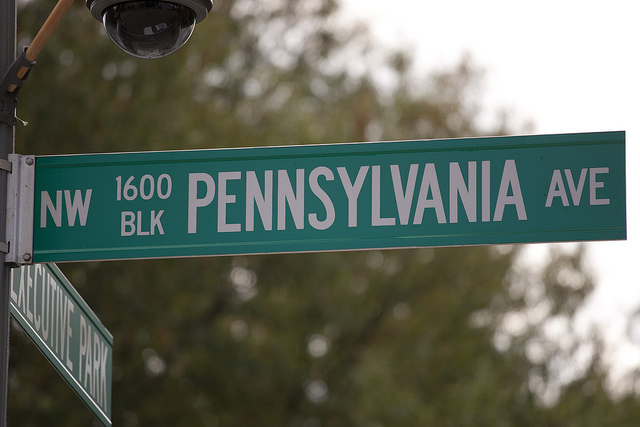Identify and read out the text in this image. 1600 NW PENNSYLVANIA BLK AVE 